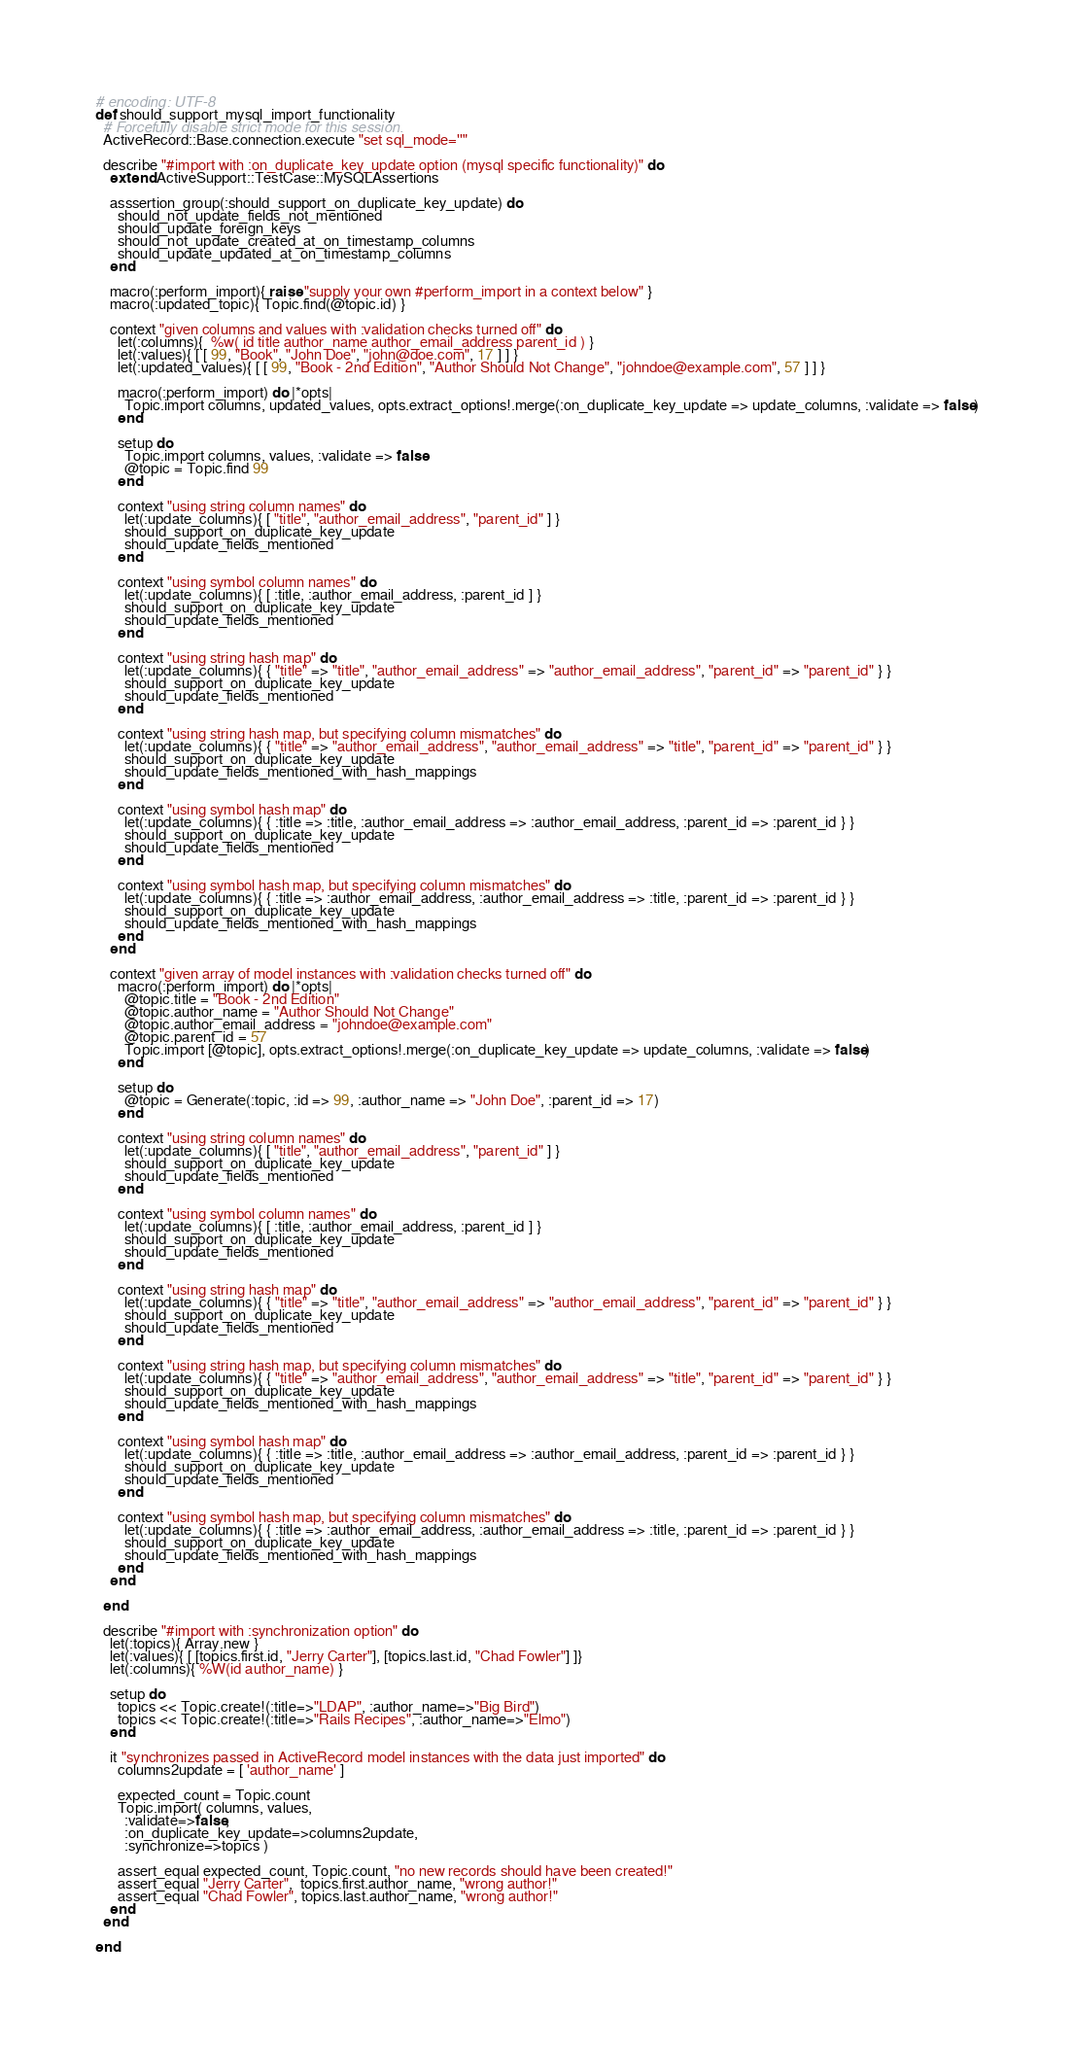Convert code to text. <code><loc_0><loc_0><loc_500><loc_500><_Ruby_># encoding: UTF-8
def should_support_mysql_import_functionality
  # Forcefully disable strict mode for this session.
  ActiveRecord::Base.connection.execute "set sql_mode=''"

  describe "#import with :on_duplicate_key_update option (mysql specific functionality)" do
    extend ActiveSupport::TestCase::MySQLAssertions

    asssertion_group(:should_support_on_duplicate_key_update) do
      should_not_update_fields_not_mentioned
      should_update_foreign_keys
      should_not_update_created_at_on_timestamp_columns
      should_update_updated_at_on_timestamp_columns
    end

    macro(:perform_import){ raise "supply your own #perform_import in a context below" }
    macro(:updated_topic){ Topic.find(@topic.id) }

    context "given columns and values with :validation checks turned off" do
      let(:columns){  %w( id title author_name author_email_address parent_id ) }
      let(:values){ [ [ 99, "Book", "John Doe", "john@doe.com", 17 ] ] }
      let(:updated_values){ [ [ 99, "Book - 2nd Edition", "Author Should Not Change", "johndoe@example.com", 57 ] ] }

      macro(:perform_import) do |*opts|
        Topic.import columns, updated_values, opts.extract_options!.merge(:on_duplicate_key_update => update_columns, :validate => false)
      end

      setup do
        Topic.import columns, values, :validate => false
        @topic = Topic.find 99
      end

      context "using string column names" do
        let(:update_columns){ [ "title", "author_email_address", "parent_id" ] }
        should_support_on_duplicate_key_update
        should_update_fields_mentioned
      end

      context "using symbol column names" do
        let(:update_columns){ [ :title, :author_email_address, :parent_id ] }
        should_support_on_duplicate_key_update
        should_update_fields_mentioned
      end

      context "using string hash map" do
        let(:update_columns){ { "title" => "title", "author_email_address" => "author_email_address", "parent_id" => "parent_id" } }
        should_support_on_duplicate_key_update
        should_update_fields_mentioned
      end

      context "using string hash map, but specifying column mismatches" do
        let(:update_columns){ { "title" => "author_email_address", "author_email_address" => "title", "parent_id" => "parent_id" } }
        should_support_on_duplicate_key_update
        should_update_fields_mentioned_with_hash_mappings
      end

      context "using symbol hash map" do
        let(:update_columns){ { :title => :title, :author_email_address => :author_email_address, :parent_id => :parent_id } }
        should_support_on_duplicate_key_update
        should_update_fields_mentioned
      end

      context "using symbol hash map, but specifying column mismatches" do
        let(:update_columns){ { :title => :author_email_address, :author_email_address => :title, :parent_id => :parent_id } }
        should_support_on_duplicate_key_update
        should_update_fields_mentioned_with_hash_mappings
      end
    end

    context "given array of model instances with :validation checks turned off" do
      macro(:perform_import) do |*opts|
        @topic.title = "Book - 2nd Edition"
        @topic.author_name = "Author Should Not Change"
        @topic.author_email_address = "johndoe@example.com"
        @topic.parent_id = 57
        Topic.import [@topic], opts.extract_options!.merge(:on_duplicate_key_update => update_columns, :validate => false)
      end

      setup do
        @topic = Generate(:topic, :id => 99, :author_name => "John Doe", :parent_id => 17)
      end

      context "using string column names" do
        let(:update_columns){ [ "title", "author_email_address", "parent_id" ] }
        should_support_on_duplicate_key_update
        should_update_fields_mentioned
      end

      context "using symbol column names" do
        let(:update_columns){ [ :title, :author_email_address, :parent_id ] }
        should_support_on_duplicate_key_update
        should_update_fields_mentioned
      end

      context "using string hash map" do
        let(:update_columns){ { "title" => "title", "author_email_address" => "author_email_address", "parent_id" => "parent_id" } }
        should_support_on_duplicate_key_update
        should_update_fields_mentioned
      end

      context "using string hash map, but specifying column mismatches" do
        let(:update_columns){ { "title" => "author_email_address", "author_email_address" => "title", "parent_id" => "parent_id" } }
        should_support_on_duplicate_key_update
        should_update_fields_mentioned_with_hash_mappings
      end

      context "using symbol hash map" do
        let(:update_columns){ { :title => :title, :author_email_address => :author_email_address, :parent_id => :parent_id } }
        should_support_on_duplicate_key_update
        should_update_fields_mentioned
      end

      context "using symbol hash map, but specifying column mismatches" do
        let(:update_columns){ { :title => :author_email_address, :author_email_address => :title, :parent_id => :parent_id } }
        should_support_on_duplicate_key_update
        should_update_fields_mentioned_with_hash_mappings
      end
    end

  end

  describe "#import with :synchronization option" do
    let(:topics){ Array.new }
    let(:values){ [ [topics.first.id, "Jerry Carter"], [topics.last.id, "Chad Fowler"] ]}
    let(:columns){ %W(id author_name) }

    setup do
      topics << Topic.create!(:title=>"LDAP", :author_name=>"Big Bird")
      topics << Topic.create!(:title=>"Rails Recipes", :author_name=>"Elmo")
    end

    it "synchronizes passed in ActiveRecord model instances with the data just imported" do
      columns2update = [ 'author_name' ]

      expected_count = Topic.count
      Topic.import( columns, values,
        :validate=>false,
        :on_duplicate_key_update=>columns2update,
        :synchronize=>topics )

      assert_equal expected_count, Topic.count, "no new records should have been created!"
      assert_equal "Jerry Carter",  topics.first.author_name, "wrong author!"
      assert_equal "Chad Fowler", topics.last.author_name, "wrong author!"
    end
  end

end
</code> 